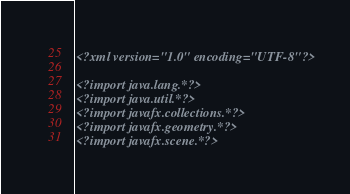<code> <loc_0><loc_0><loc_500><loc_500><_XML_><?xml version="1.0" encoding="UTF-8"?>

<?import java.lang.*?>
<?import java.util.*?>
<?import javafx.collections.*?>
<?import javafx.geometry.*?>
<?import javafx.scene.*?></code> 